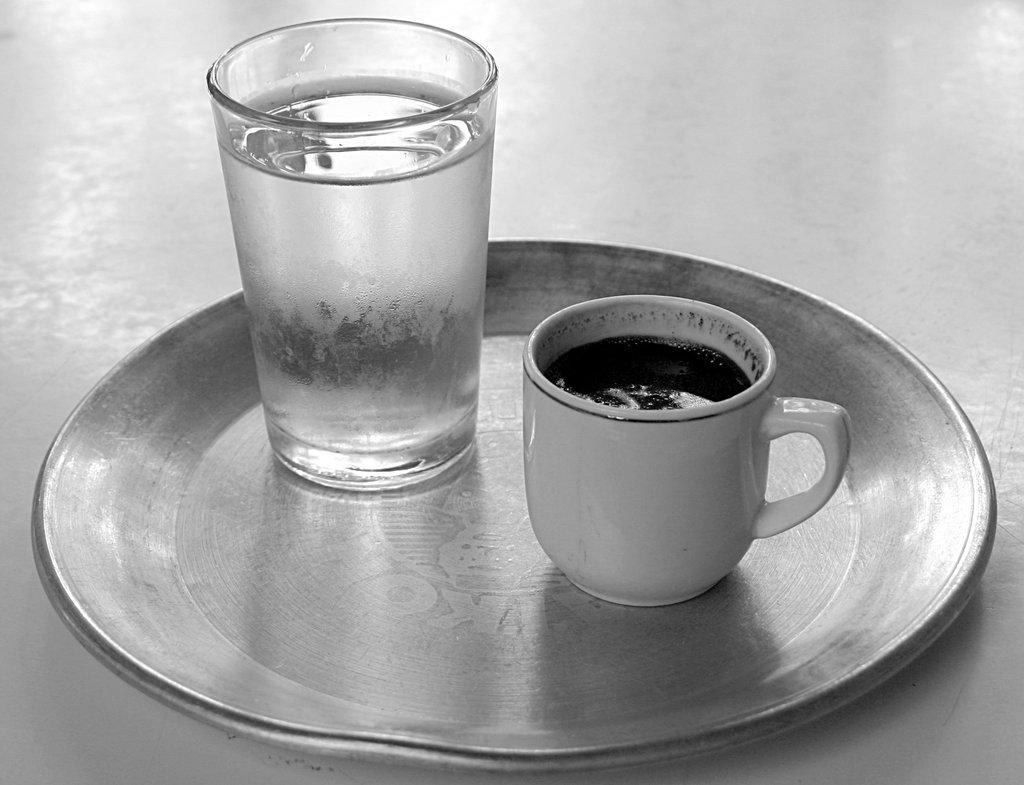What type of container is visible in the image in the image? There is a glass and a cup visible in the image. Where are the glass and cup located? Both the glass and cup are on a table. Can you describe the table in the image? There is a table visible in the image, and it has the glass and cup on it. What level of difficulty is the crib set to in the image? There is no crib present in the image, so it is not possible to determine the level of difficulty. 